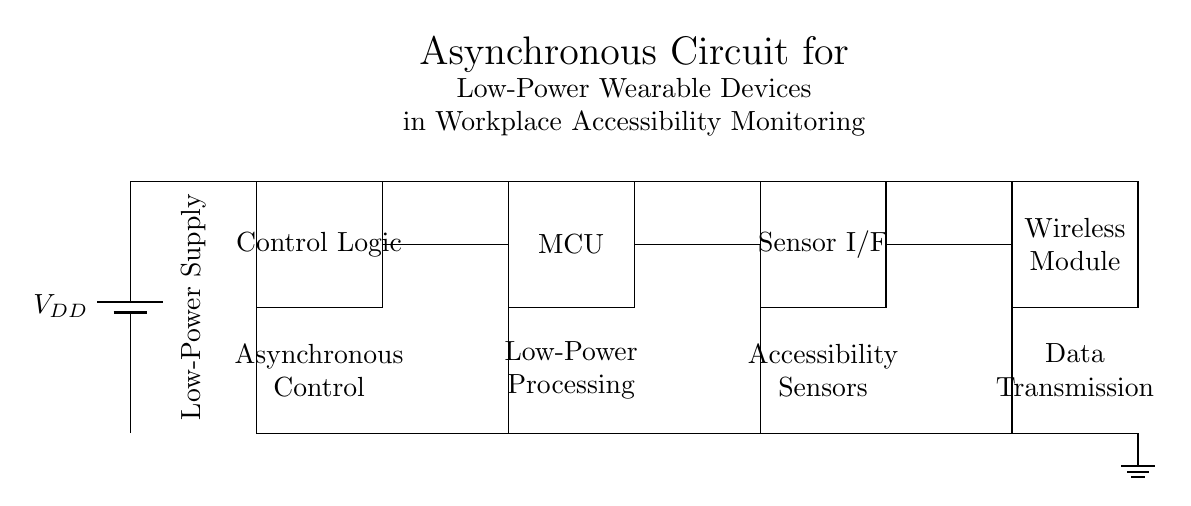What is the power supply type used in this circuit? The circuit uses a battery as the power supply, as indicated by the symbol labeled VDD.
Answer: Battery What component interfaces with sensors in this circuit? The Sensor Interface component connects to various sensors that monitor accessibility, as labeled in the diagram.
Answer: Sensor Interface How many main components are present in the circuit? There are four main components in the circuit: Control Logic, MCU, Sensor Interface, and Wireless Module, making a total of four.
Answer: Four What type of logic is implemented in the control section? The control section implements asynchronous control logic, which is designed to respond without a clock signal.
Answer: Asynchronous What is the function of the wireless module in this circuit? The wireless module is responsible for data transmission, allowing the wearable device to communicate with other systems or networks.
Answer: Data Transmission Which component receives power directly from the battery? The Control Logic component receives power directly from the battery, as indicated by the connections drawn in the diagram.
Answer: Control Logic What is the role of the low-power microcontroller in this circuit? The low-power microcontroller (MCU) performs processing tasks, enabling efficient operation of the wearable device while conserving energy.
Answer: Processing 